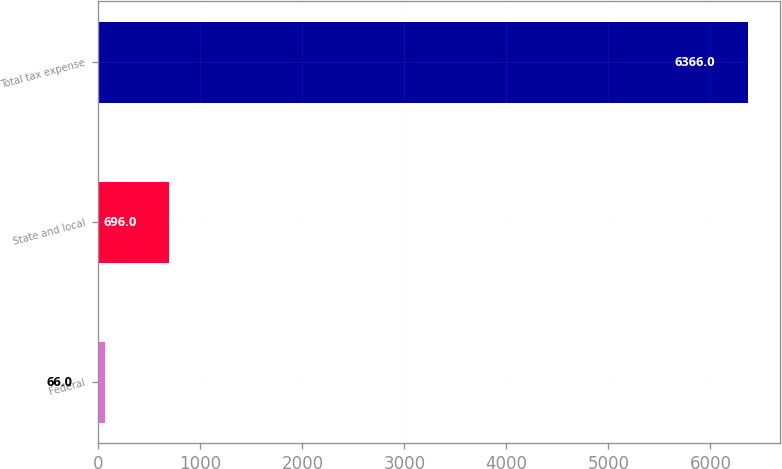<chart> <loc_0><loc_0><loc_500><loc_500><bar_chart><fcel>Federal<fcel>State and local<fcel>Total tax expense<nl><fcel>66<fcel>696<fcel>6366<nl></chart> 